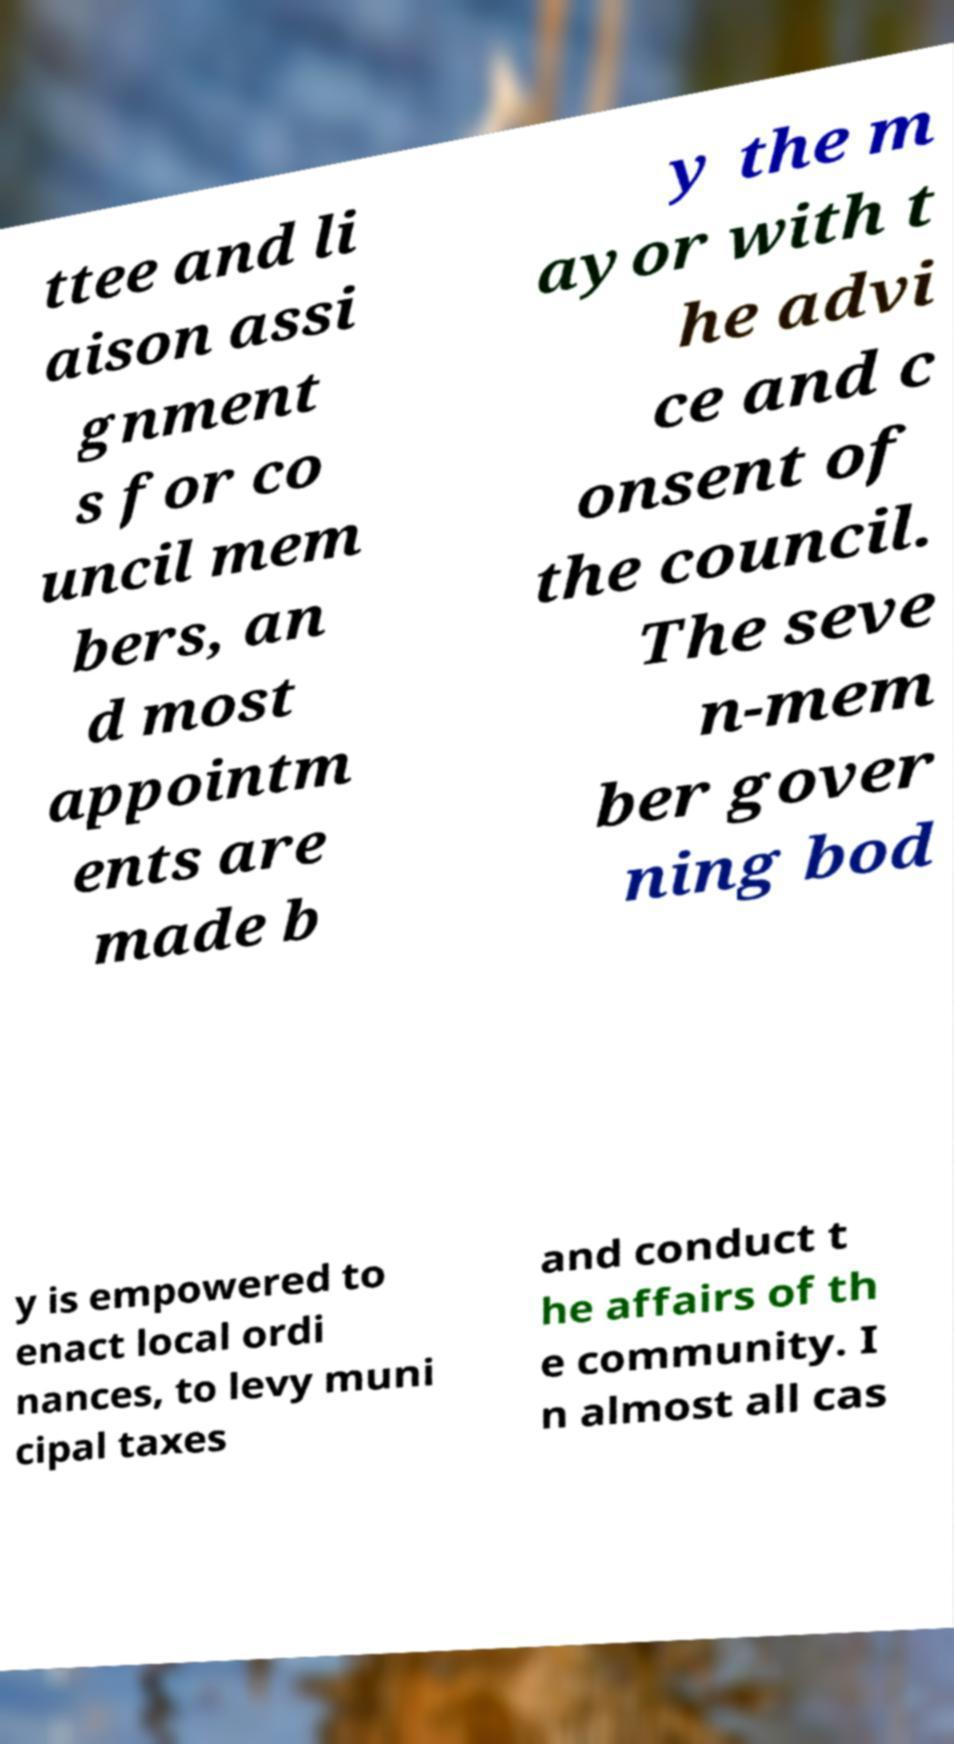Please read and relay the text visible in this image. What does it say? ttee and li aison assi gnment s for co uncil mem bers, an d most appointm ents are made b y the m ayor with t he advi ce and c onsent of the council. The seve n-mem ber gover ning bod y is empowered to enact local ordi nances, to levy muni cipal taxes and conduct t he affairs of th e community. I n almost all cas 